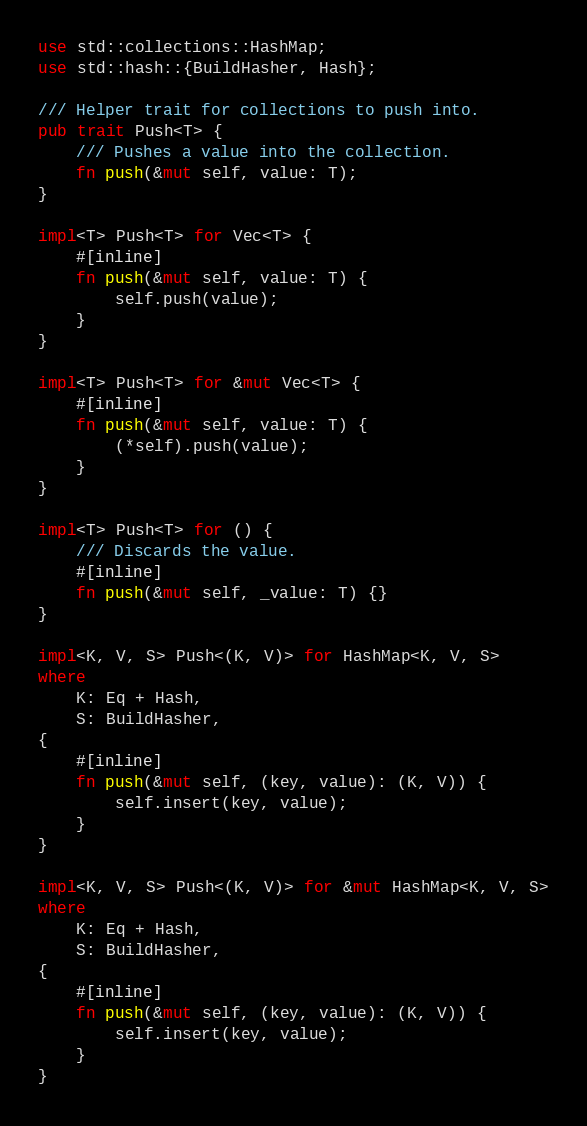<code> <loc_0><loc_0><loc_500><loc_500><_Rust_>use std::collections::HashMap;
use std::hash::{BuildHasher, Hash};

/// Helper trait for collections to push into.
pub trait Push<T> {
    /// Pushes a value into the collection.
    fn push(&mut self, value: T);
}

impl<T> Push<T> for Vec<T> {
    #[inline]
    fn push(&mut self, value: T) {
        self.push(value);
    }
}

impl<T> Push<T> for &mut Vec<T> {
    #[inline]
    fn push(&mut self, value: T) {
        (*self).push(value);
    }
}

impl<T> Push<T> for () {
    /// Discards the value.
    #[inline]
    fn push(&mut self, _value: T) {}
}

impl<K, V, S> Push<(K, V)> for HashMap<K, V, S>
where
    K: Eq + Hash,
    S: BuildHasher,
{
    #[inline]
    fn push(&mut self, (key, value): (K, V)) {
        self.insert(key, value);
    }
}

impl<K, V, S> Push<(K, V)> for &mut HashMap<K, V, S>
where
    K: Eq + Hash,
    S: BuildHasher,
{
    #[inline]
    fn push(&mut self, (key, value): (K, V)) {
        self.insert(key, value);
    }
}
</code> 